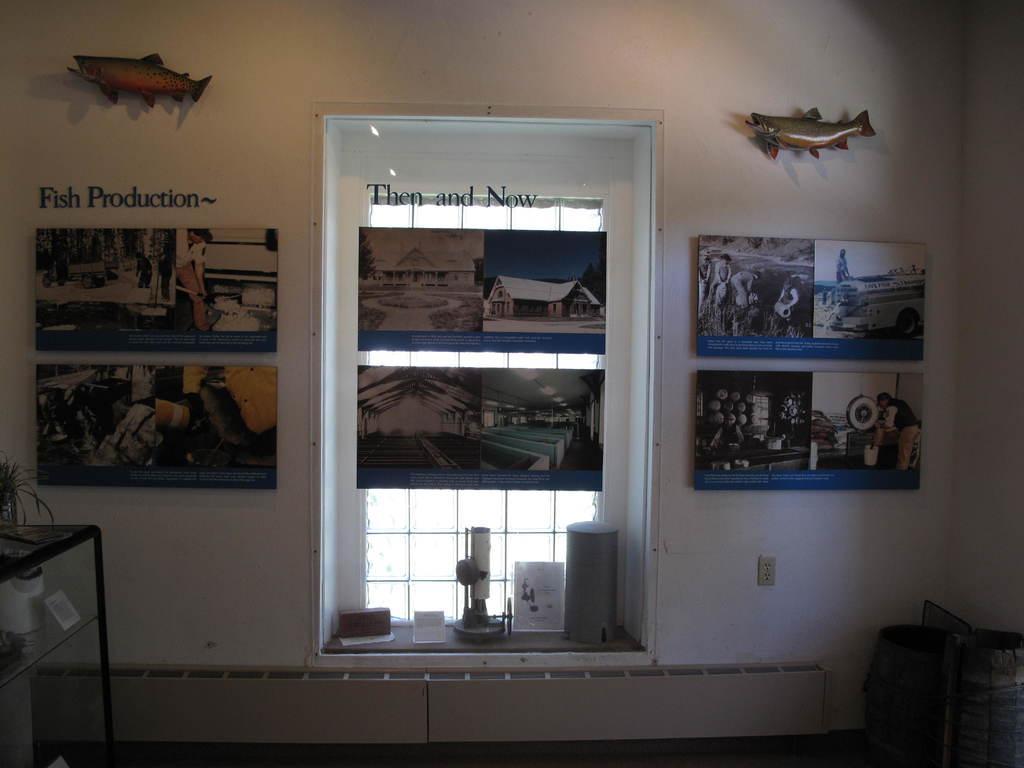How would you summarize this image in a sentence or two? In this picture we can see photo frames, fish toys on the wall, here we can see a window, table, plant and some objects. 